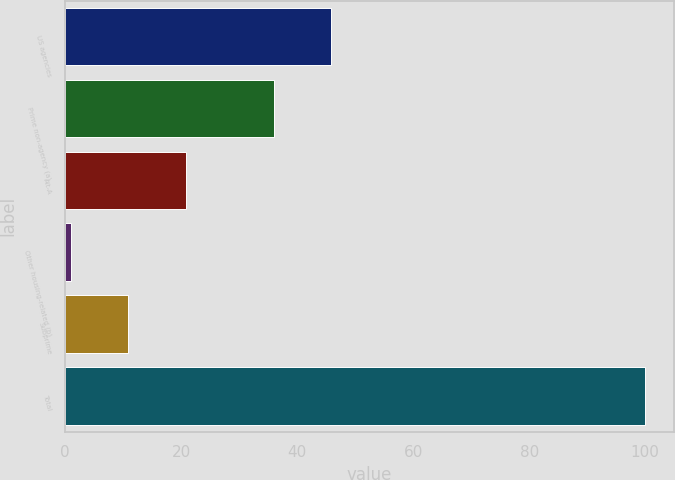Convert chart to OTSL. <chart><loc_0><loc_0><loc_500><loc_500><bar_chart><fcel>US agencies<fcel>Prime non-agency (a)<fcel>Alt-A<fcel>Other housing-related (b)<fcel>Subprime<fcel>Total<nl><fcel>45.9<fcel>36<fcel>20.8<fcel>1<fcel>10.9<fcel>100<nl></chart> 